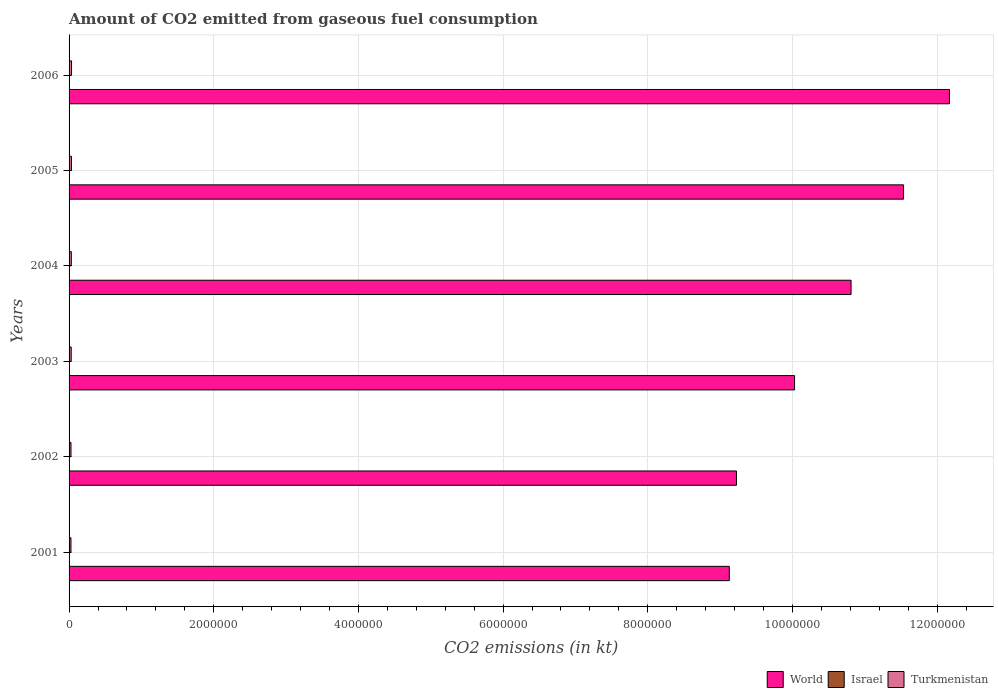How many groups of bars are there?
Provide a succinct answer. 6. How many bars are there on the 5th tick from the top?
Your response must be concise. 3. How many bars are there on the 1st tick from the bottom?
Give a very brief answer. 3. What is the amount of CO2 emitted in Israel in 2004?
Provide a succinct answer. 2240.54. Across all years, what is the maximum amount of CO2 emitted in Turkmenistan?
Keep it short and to the point. 3.40e+04. Across all years, what is the minimum amount of CO2 emitted in Israel?
Offer a terse response. 14.67. In which year was the amount of CO2 emitted in Israel maximum?
Your answer should be very brief. 2006. In which year was the amount of CO2 emitted in Israel minimum?
Your answer should be compact. 2002. What is the total amount of CO2 emitted in Turkmenistan in the graph?
Keep it short and to the point. 1.80e+05. What is the difference between the amount of CO2 emitted in World in 2003 and that in 2005?
Your answer should be compact. -1.51e+06. What is the difference between the amount of CO2 emitted in Israel in 2001 and the amount of CO2 emitted in Turkmenistan in 2002?
Your answer should be very brief. -2.65e+04. What is the average amount of CO2 emitted in World per year?
Your response must be concise. 1.05e+07. In the year 2002, what is the difference between the amount of CO2 emitted in Israel and amount of CO2 emitted in World?
Your response must be concise. -9.23e+06. In how many years, is the amount of CO2 emitted in World greater than 7600000 kt?
Provide a short and direct response. 6. What is the ratio of the amount of CO2 emitted in Turkmenistan in 2001 to that in 2003?
Give a very brief answer. 0.89. Is the difference between the amount of CO2 emitted in Israel in 2003 and 2005 greater than the difference between the amount of CO2 emitted in World in 2003 and 2005?
Provide a short and direct response. Yes. What is the difference between the highest and the second highest amount of CO2 emitted in Turkmenistan?
Your answer should be compact. 1400.79. What is the difference between the highest and the lowest amount of CO2 emitted in Turkmenistan?
Your answer should be very brief. 7741.04. Is the sum of the amount of CO2 emitted in World in 2001 and 2005 greater than the maximum amount of CO2 emitted in Israel across all years?
Give a very brief answer. Yes. What does the 2nd bar from the top in 2005 represents?
Your answer should be compact. Israel. Is it the case that in every year, the sum of the amount of CO2 emitted in World and amount of CO2 emitted in Turkmenistan is greater than the amount of CO2 emitted in Israel?
Offer a very short reply. Yes. How many bars are there?
Ensure brevity in your answer.  18. Are the values on the major ticks of X-axis written in scientific E-notation?
Give a very brief answer. No. How are the legend labels stacked?
Your answer should be very brief. Horizontal. What is the title of the graph?
Give a very brief answer. Amount of CO2 emitted from gaseous fuel consumption. What is the label or title of the X-axis?
Make the answer very short. CO2 emissions (in kt). What is the label or title of the Y-axis?
Keep it short and to the point. Years. What is the CO2 emissions (in kt) of World in 2001?
Your response must be concise. 9.13e+06. What is the CO2 emissions (in kt) in Israel in 2001?
Keep it short and to the point. 18.34. What is the CO2 emissions (in kt) in Turkmenistan in 2001?
Make the answer very short. 2.63e+04. What is the CO2 emissions (in kt) in World in 2002?
Your answer should be compact. 9.23e+06. What is the CO2 emissions (in kt) of Israel in 2002?
Ensure brevity in your answer.  14.67. What is the CO2 emissions (in kt) in Turkmenistan in 2002?
Provide a succinct answer. 2.65e+04. What is the CO2 emissions (in kt) of World in 2003?
Offer a very short reply. 1.00e+07. What is the CO2 emissions (in kt) in Israel in 2003?
Provide a succinct answer. 14.67. What is the CO2 emissions (in kt) in Turkmenistan in 2003?
Offer a very short reply. 2.94e+04. What is the CO2 emissions (in kt) of World in 2004?
Your answer should be very brief. 1.08e+07. What is the CO2 emissions (in kt) in Israel in 2004?
Provide a short and direct response. 2240.54. What is the CO2 emissions (in kt) of Turkmenistan in 2004?
Offer a terse response. 3.09e+04. What is the CO2 emissions (in kt) in World in 2005?
Make the answer very short. 1.15e+07. What is the CO2 emissions (in kt) of Israel in 2005?
Offer a terse response. 3083.95. What is the CO2 emissions (in kt) of Turkmenistan in 2005?
Your answer should be very brief. 3.26e+04. What is the CO2 emissions (in kt) in World in 2006?
Your response must be concise. 1.22e+07. What is the CO2 emissions (in kt) of Israel in 2006?
Ensure brevity in your answer.  4371.06. What is the CO2 emissions (in kt) of Turkmenistan in 2006?
Offer a very short reply. 3.40e+04. Across all years, what is the maximum CO2 emissions (in kt) in World?
Your response must be concise. 1.22e+07. Across all years, what is the maximum CO2 emissions (in kt) in Israel?
Ensure brevity in your answer.  4371.06. Across all years, what is the maximum CO2 emissions (in kt) of Turkmenistan?
Your answer should be very brief. 3.40e+04. Across all years, what is the minimum CO2 emissions (in kt) in World?
Provide a succinct answer. 9.13e+06. Across all years, what is the minimum CO2 emissions (in kt) in Israel?
Your response must be concise. 14.67. Across all years, what is the minimum CO2 emissions (in kt) of Turkmenistan?
Make the answer very short. 2.63e+04. What is the total CO2 emissions (in kt) of World in the graph?
Make the answer very short. 6.29e+07. What is the total CO2 emissions (in kt) of Israel in the graph?
Your response must be concise. 9743.22. What is the total CO2 emissions (in kt) in Turkmenistan in the graph?
Your answer should be very brief. 1.80e+05. What is the difference between the CO2 emissions (in kt) of World in 2001 and that in 2002?
Provide a succinct answer. -9.90e+04. What is the difference between the CO2 emissions (in kt) in Israel in 2001 and that in 2002?
Your response must be concise. 3.67. What is the difference between the CO2 emissions (in kt) of Turkmenistan in 2001 and that in 2002?
Offer a terse response. -187.02. What is the difference between the CO2 emissions (in kt) of World in 2001 and that in 2003?
Offer a terse response. -9.02e+05. What is the difference between the CO2 emissions (in kt) in Israel in 2001 and that in 2003?
Your answer should be compact. 3.67. What is the difference between the CO2 emissions (in kt) in Turkmenistan in 2001 and that in 2003?
Provide a short and direct response. -3094.95. What is the difference between the CO2 emissions (in kt) of World in 2001 and that in 2004?
Ensure brevity in your answer.  -1.68e+06. What is the difference between the CO2 emissions (in kt) in Israel in 2001 and that in 2004?
Your answer should be very brief. -2222.2. What is the difference between the CO2 emissions (in kt) of Turkmenistan in 2001 and that in 2004?
Your answer should be compact. -4605.75. What is the difference between the CO2 emissions (in kt) in World in 2001 and that in 2005?
Keep it short and to the point. -2.41e+06. What is the difference between the CO2 emissions (in kt) in Israel in 2001 and that in 2005?
Provide a short and direct response. -3065.61. What is the difference between the CO2 emissions (in kt) of Turkmenistan in 2001 and that in 2005?
Make the answer very short. -6340.24. What is the difference between the CO2 emissions (in kt) of World in 2001 and that in 2006?
Your answer should be compact. -3.04e+06. What is the difference between the CO2 emissions (in kt) in Israel in 2001 and that in 2006?
Ensure brevity in your answer.  -4352.73. What is the difference between the CO2 emissions (in kt) in Turkmenistan in 2001 and that in 2006?
Your answer should be very brief. -7741.04. What is the difference between the CO2 emissions (in kt) in World in 2002 and that in 2003?
Provide a succinct answer. -8.03e+05. What is the difference between the CO2 emissions (in kt) in Israel in 2002 and that in 2003?
Provide a succinct answer. 0. What is the difference between the CO2 emissions (in kt) in Turkmenistan in 2002 and that in 2003?
Offer a very short reply. -2907.93. What is the difference between the CO2 emissions (in kt) in World in 2002 and that in 2004?
Provide a succinct answer. -1.58e+06. What is the difference between the CO2 emissions (in kt) in Israel in 2002 and that in 2004?
Give a very brief answer. -2225.87. What is the difference between the CO2 emissions (in kt) of Turkmenistan in 2002 and that in 2004?
Provide a succinct answer. -4418.73. What is the difference between the CO2 emissions (in kt) of World in 2002 and that in 2005?
Make the answer very short. -2.31e+06. What is the difference between the CO2 emissions (in kt) of Israel in 2002 and that in 2005?
Keep it short and to the point. -3069.28. What is the difference between the CO2 emissions (in kt) in Turkmenistan in 2002 and that in 2005?
Your answer should be very brief. -6153.23. What is the difference between the CO2 emissions (in kt) in World in 2002 and that in 2006?
Your response must be concise. -2.94e+06. What is the difference between the CO2 emissions (in kt) in Israel in 2002 and that in 2006?
Provide a short and direct response. -4356.4. What is the difference between the CO2 emissions (in kt) in Turkmenistan in 2002 and that in 2006?
Give a very brief answer. -7554.02. What is the difference between the CO2 emissions (in kt) in World in 2003 and that in 2004?
Your response must be concise. -7.81e+05. What is the difference between the CO2 emissions (in kt) of Israel in 2003 and that in 2004?
Offer a terse response. -2225.87. What is the difference between the CO2 emissions (in kt) of Turkmenistan in 2003 and that in 2004?
Provide a succinct answer. -1510.8. What is the difference between the CO2 emissions (in kt) in World in 2003 and that in 2005?
Offer a very short reply. -1.51e+06. What is the difference between the CO2 emissions (in kt) of Israel in 2003 and that in 2005?
Offer a terse response. -3069.28. What is the difference between the CO2 emissions (in kt) in Turkmenistan in 2003 and that in 2005?
Give a very brief answer. -3245.3. What is the difference between the CO2 emissions (in kt) in World in 2003 and that in 2006?
Your answer should be very brief. -2.14e+06. What is the difference between the CO2 emissions (in kt) of Israel in 2003 and that in 2006?
Keep it short and to the point. -4356.4. What is the difference between the CO2 emissions (in kt) in Turkmenistan in 2003 and that in 2006?
Give a very brief answer. -4646.09. What is the difference between the CO2 emissions (in kt) in World in 2004 and that in 2005?
Keep it short and to the point. -7.26e+05. What is the difference between the CO2 emissions (in kt) of Israel in 2004 and that in 2005?
Your answer should be very brief. -843.41. What is the difference between the CO2 emissions (in kt) in Turkmenistan in 2004 and that in 2005?
Offer a terse response. -1734.49. What is the difference between the CO2 emissions (in kt) of World in 2004 and that in 2006?
Keep it short and to the point. -1.36e+06. What is the difference between the CO2 emissions (in kt) of Israel in 2004 and that in 2006?
Give a very brief answer. -2130.53. What is the difference between the CO2 emissions (in kt) in Turkmenistan in 2004 and that in 2006?
Your answer should be very brief. -3135.28. What is the difference between the CO2 emissions (in kt) in World in 2005 and that in 2006?
Give a very brief answer. -6.34e+05. What is the difference between the CO2 emissions (in kt) of Israel in 2005 and that in 2006?
Your response must be concise. -1287.12. What is the difference between the CO2 emissions (in kt) in Turkmenistan in 2005 and that in 2006?
Your answer should be very brief. -1400.79. What is the difference between the CO2 emissions (in kt) in World in 2001 and the CO2 emissions (in kt) in Israel in 2002?
Keep it short and to the point. 9.13e+06. What is the difference between the CO2 emissions (in kt) in World in 2001 and the CO2 emissions (in kt) in Turkmenistan in 2002?
Give a very brief answer. 9.10e+06. What is the difference between the CO2 emissions (in kt) in Israel in 2001 and the CO2 emissions (in kt) in Turkmenistan in 2002?
Provide a succinct answer. -2.65e+04. What is the difference between the CO2 emissions (in kt) in World in 2001 and the CO2 emissions (in kt) in Israel in 2003?
Your answer should be compact. 9.13e+06. What is the difference between the CO2 emissions (in kt) of World in 2001 and the CO2 emissions (in kt) of Turkmenistan in 2003?
Your answer should be compact. 9.10e+06. What is the difference between the CO2 emissions (in kt) in Israel in 2001 and the CO2 emissions (in kt) in Turkmenistan in 2003?
Provide a short and direct response. -2.94e+04. What is the difference between the CO2 emissions (in kt) in World in 2001 and the CO2 emissions (in kt) in Israel in 2004?
Your answer should be very brief. 9.12e+06. What is the difference between the CO2 emissions (in kt) in World in 2001 and the CO2 emissions (in kt) in Turkmenistan in 2004?
Your response must be concise. 9.10e+06. What is the difference between the CO2 emissions (in kt) in Israel in 2001 and the CO2 emissions (in kt) in Turkmenistan in 2004?
Your response must be concise. -3.09e+04. What is the difference between the CO2 emissions (in kt) of World in 2001 and the CO2 emissions (in kt) of Israel in 2005?
Your answer should be very brief. 9.12e+06. What is the difference between the CO2 emissions (in kt) of World in 2001 and the CO2 emissions (in kt) of Turkmenistan in 2005?
Give a very brief answer. 9.09e+06. What is the difference between the CO2 emissions (in kt) of Israel in 2001 and the CO2 emissions (in kt) of Turkmenistan in 2005?
Ensure brevity in your answer.  -3.26e+04. What is the difference between the CO2 emissions (in kt) of World in 2001 and the CO2 emissions (in kt) of Israel in 2006?
Make the answer very short. 9.12e+06. What is the difference between the CO2 emissions (in kt) in World in 2001 and the CO2 emissions (in kt) in Turkmenistan in 2006?
Your answer should be compact. 9.09e+06. What is the difference between the CO2 emissions (in kt) in Israel in 2001 and the CO2 emissions (in kt) in Turkmenistan in 2006?
Keep it short and to the point. -3.40e+04. What is the difference between the CO2 emissions (in kt) in World in 2002 and the CO2 emissions (in kt) in Israel in 2003?
Your answer should be compact. 9.23e+06. What is the difference between the CO2 emissions (in kt) of World in 2002 and the CO2 emissions (in kt) of Turkmenistan in 2003?
Offer a terse response. 9.20e+06. What is the difference between the CO2 emissions (in kt) in Israel in 2002 and the CO2 emissions (in kt) in Turkmenistan in 2003?
Your response must be concise. -2.94e+04. What is the difference between the CO2 emissions (in kt) in World in 2002 and the CO2 emissions (in kt) in Israel in 2004?
Offer a very short reply. 9.22e+06. What is the difference between the CO2 emissions (in kt) in World in 2002 and the CO2 emissions (in kt) in Turkmenistan in 2004?
Your answer should be very brief. 9.20e+06. What is the difference between the CO2 emissions (in kt) of Israel in 2002 and the CO2 emissions (in kt) of Turkmenistan in 2004?
Ensure brevity in your answer.  -3.09e+04. What is the difference between the CO2 emissions (in kt) of World in 2002 and the CO2 emissions (in kt) of Israel in 2005?
Offer a terse response. 9.22e+06. What is the difference between the CO2 emissions (in kt) in World in 2002 and the CO2 emissions (in kt) in Turkmenistan in 2005?
Offer a terse response. 9.19e+06. What is the difference between the CO2 emissions (in kt) in Israel in 2002 and the CO2 emissions (in kt) in Turkmenistan in 2005?
Make the answer very short. -3.26e+04. What is the difference between the CO2 emissions (in kt) in World in 2002 and the CO2 emissions (in kt) in Israel in 2006?
Provide a short and direct response. 9.22e+06. What is the difference between the CO2 emissions (in kt) in World in 2002 and the CO2 emissions (in kt) in Turkmenistan in 2006?
Provide a short and direct response. 9.19e+06. What is the difference between the CO2 emissions (in kt) of Israel in 2002 and the CO2 emissions (in kt) of Turkmenistan in 2006?
Provide a succinct answer. -3.40e+04. What is the difference between the CO2 emissions (in kt) of World in 2003 and the CO2 emissions (in kt) of Israel in 2004?
Your answer should be compact. 1.00e+07. What is the difference between the CO2 emissions (in kt) of World in 2003 and the CO2 emissions (in kt) of Turkmenistan in 2004?
Ensure brevity in your answer.  1.00e+07. What is the difference between the CO2 emissions (in kt) of Israel in 2003 and the CO2 emissions (in kt) of Turkmenistan in 2004?
Make the answer very short. -3.09e+04. What is the difference between the CO2 emissions (in kt) in World in 2003 and the CO2 emissions (in kt) in Israel in 2005?
Make the answer very short. 1.00e+07. What is the difference between the CO2 emissions (in kt) in World in 2003 and the CO2 emissions (in kt) in Turkmenistan in 2005?
Offer a very short reply. 1.00e+07. What is the difference between the CO2 emissions (in kt) of Israel in 2003 and the CO2 emissions (in kt) of Turkmenistan in 2005?
Your response must be concise. -3.26e+04. What is the difference between the CO2 emissions (in kt) of World in 2003 and the CO2 emissions (in kt) of Israel in 2006?
Provide a succinct answer. 1.00e+07. What is the difference between the CO2 emissions (in kt) in World in 2003 and the CO2 emissions (in kt) in Turkmenistan in 2006?
Ensure brevity in your answer.  1.00e+07. What is the difference between the CO2 emissions (in kt) in Israel in 2003 and the CO2 emissions (in kt) in Turkmenistan in 2006?
Make the answer very short. -3.40e+04. What is the difference between the CO2 emissions (in kt) of World in 2004 and the CO2 emissions (in kt) of Israel in 2005?
Offer a terse response. 1.08e+07. What is the difference between the CO2 emissions (in kt) in World in 2004 and the CO2 emissions (in kt) in Turkmenistan in 2005?
Ensure brevity in your answer.  1.08e+07. What is the difference between the CO2 emissions (in kt) of Israel in 2004 and the CO2 emissions (in kt) of Turkmenistan in 2005?
Give a very brief answer. -3.04e+04. What is the difference between the CO2 emissions (in kt) of World in 2004 and the CO2 emissions (in kt) of Israel in 2006?
Your answer should be very brief. 1.08e+07. What is the difference between the CO2 emissions (in kt) in World in 2004 and the CO2 emissions (in kt) in Turkmenistan in 2006?
Keep it short and to the point. 1.08e+07. What is the difference between the CO2 emissions (in kt) of Israel in 2004 and the CO2 emissions (in kt) of Turkmenistan in 2006?
Your response must be concise. -3.18e+04. What is the difference between the CO2 emissions (in kt) of World in 2005 and the CO2 emissions (in kt) of Israel in 2006?
Provide a succinct answer. 1.15e+07. What is the difference between the CO2 emissions (in kt) in World in 2005 and the CO2 emissions (in kt) in Turkmenistan in 2006?
Your response must be concise. 1.15e+07. What is the difference between the CO2 emissions (in kt) of Israel in 2005 and the CO2 emissions (in kt) of Turkmenistan in 2006?
Offer a very short reply. -3.10e+04. What is the average CO2 emissions (in kt) in World per year?
Offer a terse response. 1.05e+07. What is the average CO2 emissions (in kt) in Israel per year?
Make the answer very short. 1623.87. What is the average CO2 emissions (in kt) of Turkmenistan per year?
Make the answer very short. 3.00e+04. In the year 2001, what is the difference between the CO2 emissions (in kt) in World and CO2 emissions (in kt) in Israel?
Your answer should be compact. 9.13e+06. In the year 2001, what is the difference between the CO2 emissions (in kt) of World and CO2 emissions (in kt) of Turkmenistan?
Your answer should be compact. 9.10e+06. In the year 2001, what is the difference between the CO2 emissions (in kt) of Israel and CO2 emissions (in kt) of Turkmenistan?
Your response must be concise. -2.63e+04. In the year 2002, what is the difference between the CO2 emissions (in kt) of World and CO2 emissions (in kt) of Israel?
Offer a very short reply. 9.23e+06. In the year 2002, what is the difference between the CO2 emissions (in kt) in World and CO2 emissions (in kt) in Turkmenistan?
Keep it short and to the point. 9.20e+06. In the year 2002, what is the difference between the CO2 emissions (in kt) of Israel and CO2 emissions (in kt) of Turkmenistan?
Offer a terse response. -2.65e+04. In the year 2003, what is the difference between the CO2 emissions (in kt) in World and CO2 emissions (in kt) in Israel?
Offer a terse response. 1.00e+07. In the year 2003, what is the difference between the CO2 emissions (in kt) in World and CO2 emissions (in kt) in Turkmenistan?
Make the answer very short. 1.00e+07. In the year 2003, what is the difference between the CO2 emissions (in kt) of Israel and CO2 emissions (in kt) of Turkmenistan?
Make the answer very short. -2.94e+04. In the year 2004, what is the difference between the CO2 emissions (in kt) of World and CO2 emissions (in kt) of Israel?
Offer a terse response. 1.08e+07. In the year 2004, what is the difference between the CO2 emissions (in kt) of World and CO2 emissions (in kt) of Turkmenistan?
Make the answer very short. 1.08e+07. In the year 2004, what is the difference between the CO2 emissions (in kt) in Israel and CO2 emissions (in kt) in Turkmenistan?
Provide a short and direct response. -2.87e+04. In the year 2005, what is the difference between the CO2 emissions (in kt) in World and CO2 emissions (in kt) in Israel?
Offer a very short reply. 1.15e+07. In the year 2005, what is the difference between the CO2 emissions (in kt) in World and CO2 emissions (in kt) in Turkmenistan?
Make the answer very short. 1.15e+07. In the year 2005, what is the difference between the CO2 emissions (in kt) in Israel and CO2 emissions (in kt) in Turkmenistan?
Your answer should be very brief. -2.96e+04. In the year 2006, what is the difference between the CO2 emissions (in kt) of World and CO2 emissions (in kt) of Israel?
Offer a very short reply. 1.22e+07. In the year 2006, what is the difference between the CO2 emissions (in kt) of World and CO2 emissions (in kt) of Turkmenistan?
Provide a succinct answer. 1.21e+07. In the year 2006, what is the difference between the CO2 emissions (in kt) of Israel and CO2 emissions (in kt) of Turkmenistan?
Make the answer very short. -2.97e+04. What is the ratio of the CO2 emissions (in kt) of World in 2001 to that in 2002?
Offer a very short reply. 0.99. What is the ratio of the CO2 emissions (in kt) of Israel in 2001 to that in 2002?
Your response must be concise. 1.25. What is the ratio of the CO2 emissions (in kt) of Turkmenistan in 2001 to that in 2002?
Your response must be concise. 0.99. What is the ratio of the CO2 emissions (in kt) in World in 2001 to that in 2003?
Provide a succinct answer. 0.91. What is the ratio of the CO2 emissions (in kt) in Turkmenistan in 2001 to that in 2003?
Offer a terse response. 0.89. What is the ratio of the CO2 emissions (in kt) in World in 2001 to that in 2004?
Provide a short and direct response. 0.84. What is the ratio of the CO2 emissions (in kt) of Israel in 2001 to that in 2004?
Give a very brief answer. 0.01. What is the ratio of the CO2 emissions (in kt) in Turkmenistan in 2001 to that in 2004?
Give a very brief answer. 0.85. What is the ratio of the CO2 emissions (in kt) in World in 2001 to that in 2005?
Offer a very short reply. 0.79. What is the ratio of the CO2 emissions (in kt) in Israel in 2001 to that in 2005?
Ensure brevity in your answer.  0.01. What is the ratio of the CO2 emissions (in kt) in Turkmenistan in 2001 to that in 2005?
Provide a short and direct response. 0.81. What is the ratio of the CO2 emissions (in kt) of World in 2001 to that in 2006?
Make the answer very short. 0.75. What is the ratio of the CO2 emissions (in kt) of Israel in 2001 to that in 2006?
Make the answer very short. 0. What is the ratio of the CO2 emissions (in kt) of Turkmenistan in 2001 to that in 2006?
Give a very brief answer. 0.77. What is the ratio of the CO2 emissions (in kt) in World in 2002 to that in 2003?
Give a very brief answer. 0.92. What is the ratio of the CO2 emissions (in kt) of Turkmenistan in 2002 to that in 2003?
Your response must be concise. 0.9. What is the ratio of the CO2 emissions (in kt) of World in 2002 to that in 2004?
Offer a very short reply. 0.85. What is the ratio of the CO2 emissions (in kt) in Israel in 2002 to that in 2004?
Provide a succinct answer. 0.01. What is the ratio of the CO2 emissions (in kt) in Turkmenistan in 2002 to that in 2004?
Your response must be concise. 0.86. What is the ratio of the CO2 emissions (in kt) in World in 2002 to that in 2005?
Offer a very short reply. 0.8. What is the ratio of the CO2 emissions (in kt) in Israel in 2002 to that in 2005?
Make the answer very short. 0. What is the ratio of the CO2 emissions (in kt) in Turkmenistan in 2002 to that in 2005?
Give a very brief answer. 0.81. What is the ratio of the CO2 emissions (in kt) of World in 2002 to that in 2006?
Ensure brevity in your answer.  0.76. What is the ratio of the CO2 emissions (in kt) of Israel in 2002 to that in 2006?
Ensure brevity in your answer.  0. What is the ratio of the CO2 emissions (in kt) in Turkmenistan in 2002 to that in 2006?
Give a very brief answer. 0.78. What is the ratio of the CO2 emissions (in kt) in World in 2003 to that in 2004?
Give a very brief answer. 0.93. What is the ratio of the CO2 emissions (in kt) in Israel in 2003 to that in 2004?
Your answer should be compact. 0.01. What is the ratio of the CO2 emissions (in kt) of Turkmenistan in 2003 to that in 2004?
Make the answer very short. 0.95. What is the ratio of the CO2 emissions (in kt) in World in 2003 to that in 2005?
Make the answer very short. 0.87. What is the ratio of the CO2 emissions (in kt) of Israel in 2003 to that in 2005?
Your answer should be very brief. 0. What is the ratio of the CO2 emissions (in kt) of Turkmenistan in 2003 to that in 2005?
Make the answer very short. 0.9. What is the ratio of the CO2 emissions (in kt) in World in 2003 to that in 2006?
Keep it short and to the point. 0.82. What is the ratio of the CO2 emissions (in kt) in Israel in 2003 to that in 2006?
Make the answer very short. 0. What is the ratio of the CO2 emissions (in kt) of Turkmenistan in 2003 to that in 2006?
Provide a short and direct response. 0.86. What is the ratio of the CO2 emissions (in kt) of World in 2004 to that in 2005?
Your answer should be compact. 0.94. What is the ratio of the CO2 emissions (in kt) in Israel in 2004 to that in 2005?
Offer a very short reply. 0.73. What is the ratio of the CO2 emissions (in kt) of Turkmenistan in 2004 to that in 2005?
Provide a succinct answer. 0.95. What is the ratio of the CO2 emissions (in kt) in World in 2004 to that in 2006?
Your answer should be very brief. 0.89. What is the ratio of the CO2 emissions (in kt) in Israel in 2004 to that in 2006?
Make the answer very short. 0.51. What is the ratio of the CO2 emissions (in kt) in Turkmenistan in 2004 to that in 2006?
Provide a succinct answer. 0.91. What is the ratio of the CO2 emissions (in kt) in World in 2005 to that in 2006?
Give a very brief answer. 0.95. What is the ratio of the CO2 emissions (in kt) in Israel in 2005 to that in 2006?
Make the answer very short. 0.71. What is the ratio of the CO2 emissions (in kt) of Turkmenistan in 2005 to that in 2006?
Offer a very short reply. 0.96. What is the difference between the highest and the second highest CO2 emissions (in kt) in World?
Offer a very short reply. 6.34e+05. What is the difference between the highest and the second highest CO2 emissions (in kt) of Israel?
Your answer should be compact. 1287.12. What is the difference between the highest and the second highest CO2 emissions (in kt) in Turkmenistan?
Your answer should be very brief. 1400.79. What is the difference between the highest and the lowest CO2 emissions (in kt) in World?
Provide a short and direct response. 3.04e+06. What is the difference between the highest and the lowest CO2 emissions (in kt) in Israel?
Make the answer very short. 4356.4. What is the difference between the highest and the lowest CO2 emissions (in kt) of Turkmenistan?
Offer a terse response. 7741.04. 